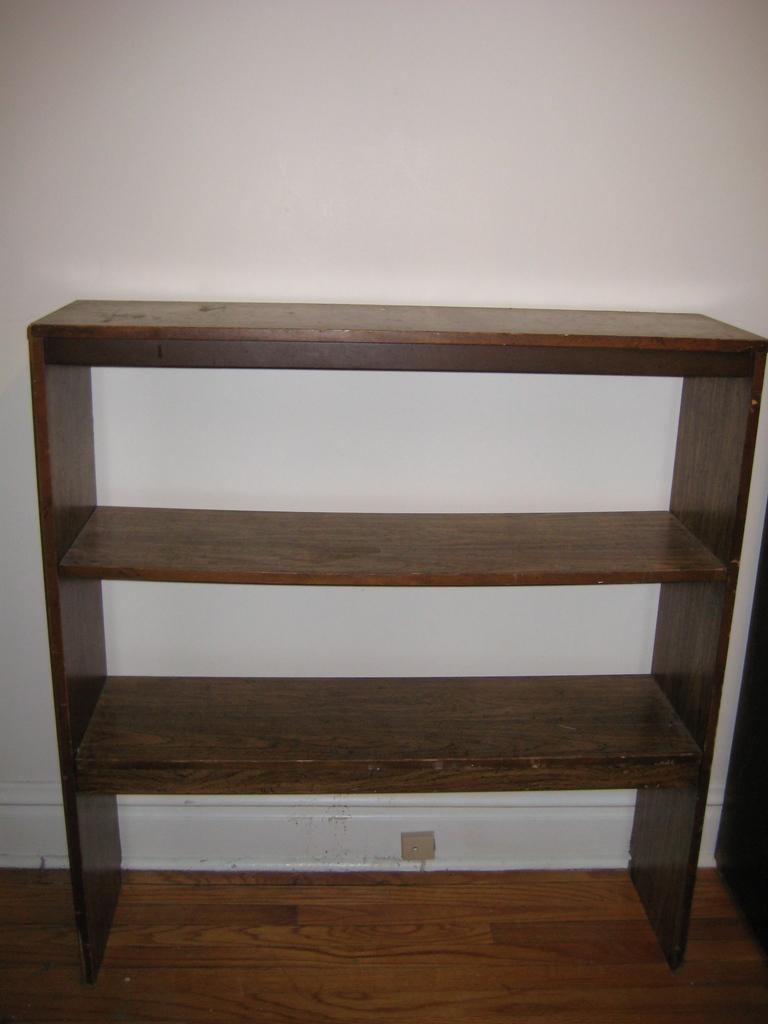What can be seen in the image that is used for storage? There is a shelf in the image that is used for storage. What type of flooring is visible in the image? The shelf is on a wooden floor. What is visible in the background of the image? There is a wall in the background of the image. How many girls are playing with planes in the hall in the image? There are no girls, planes, or halls present in the image. 